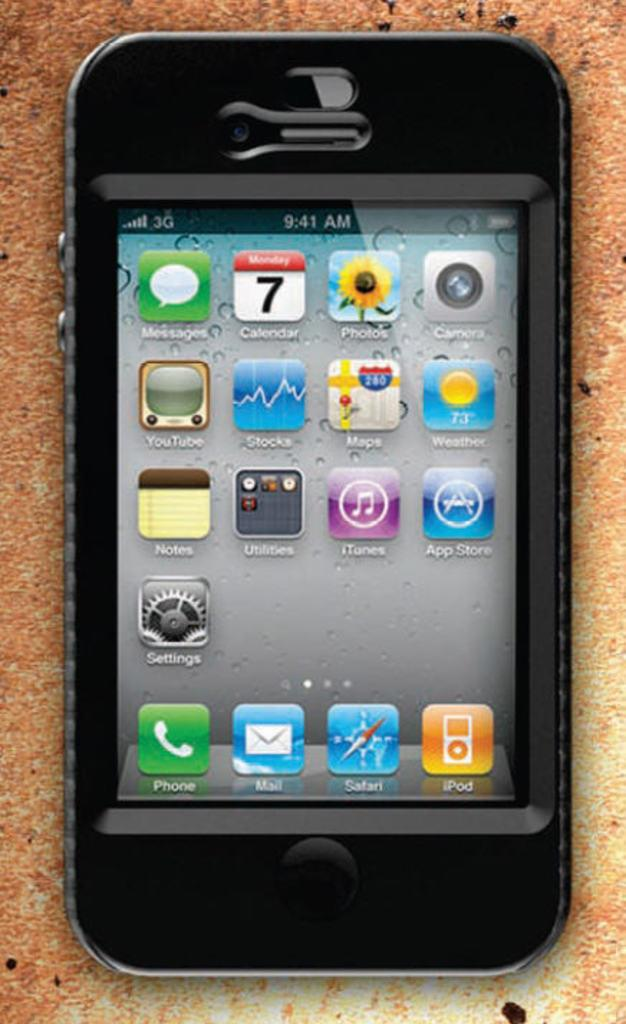<image>
Share a concise interpretation of the image provided. An Iphone sitting on a sandy surface has the time of 9:41 am. 